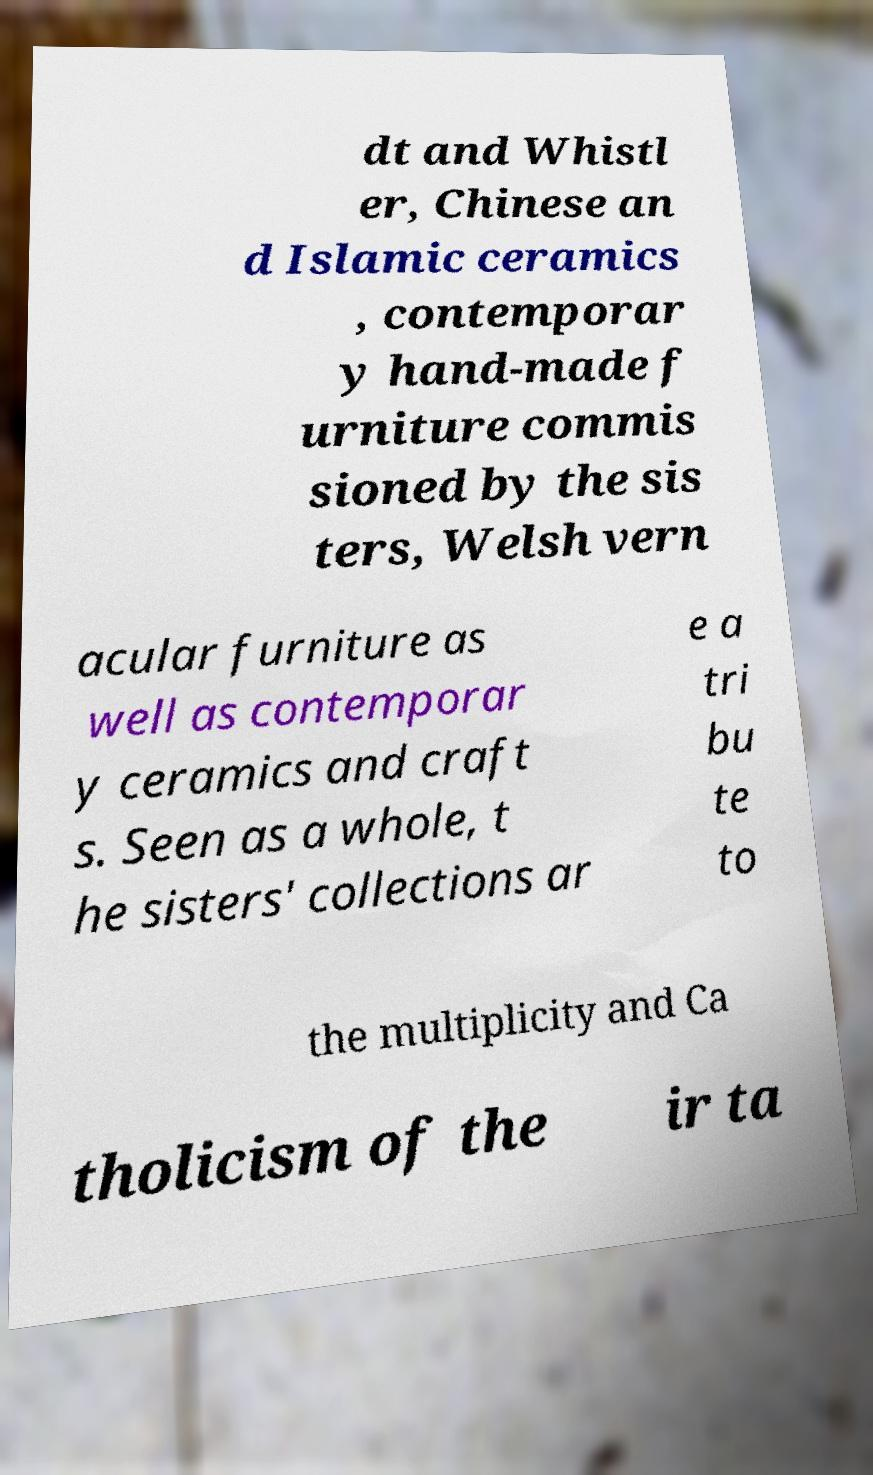Can you accurately transcribe the text from the provided image for me? dt and Whistl er, Chinese an d Islamic ceramics , contemporar y hand-made f urniture commis sioned by the sis ters, Welsh vern acular furniture as well as contemporar y ceramics and craft s. Seen as a whole, t he sisters' collections ar e a tri bu te to the multiplicity and Ca tholicism of the ir ta 